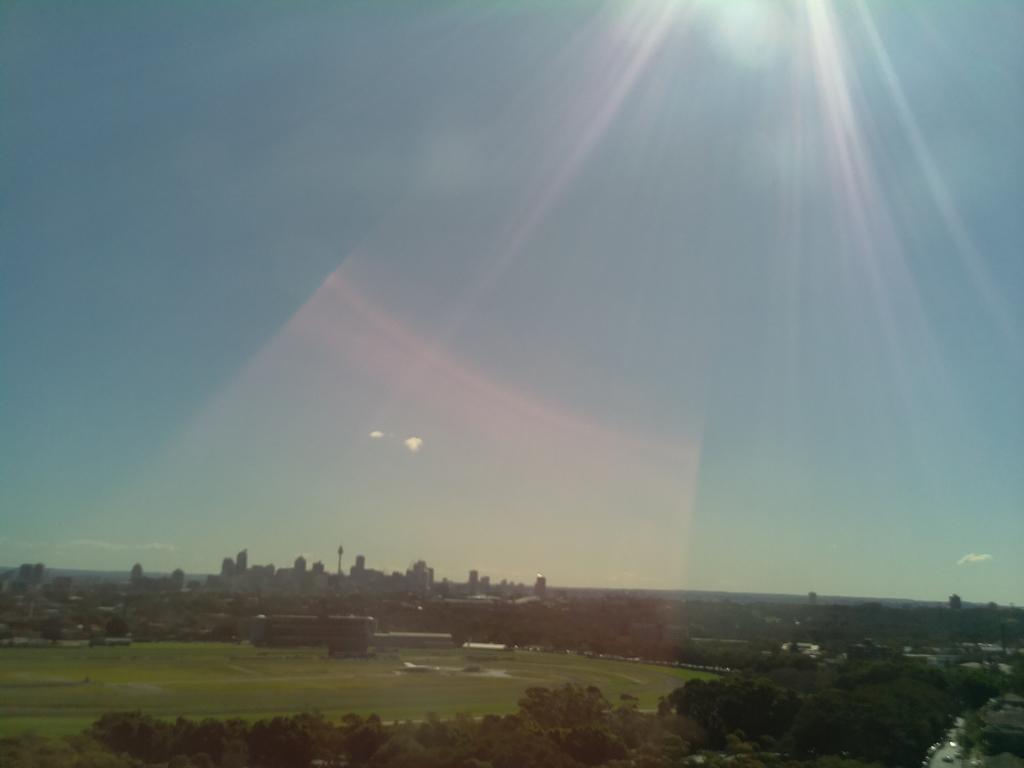Describe this image in one or two sentences. In this picture we can see ground and stadium. At the bottom we can see many trees. In the background we can see tower, skyscrapers and buildings. At the top there is a sky. 